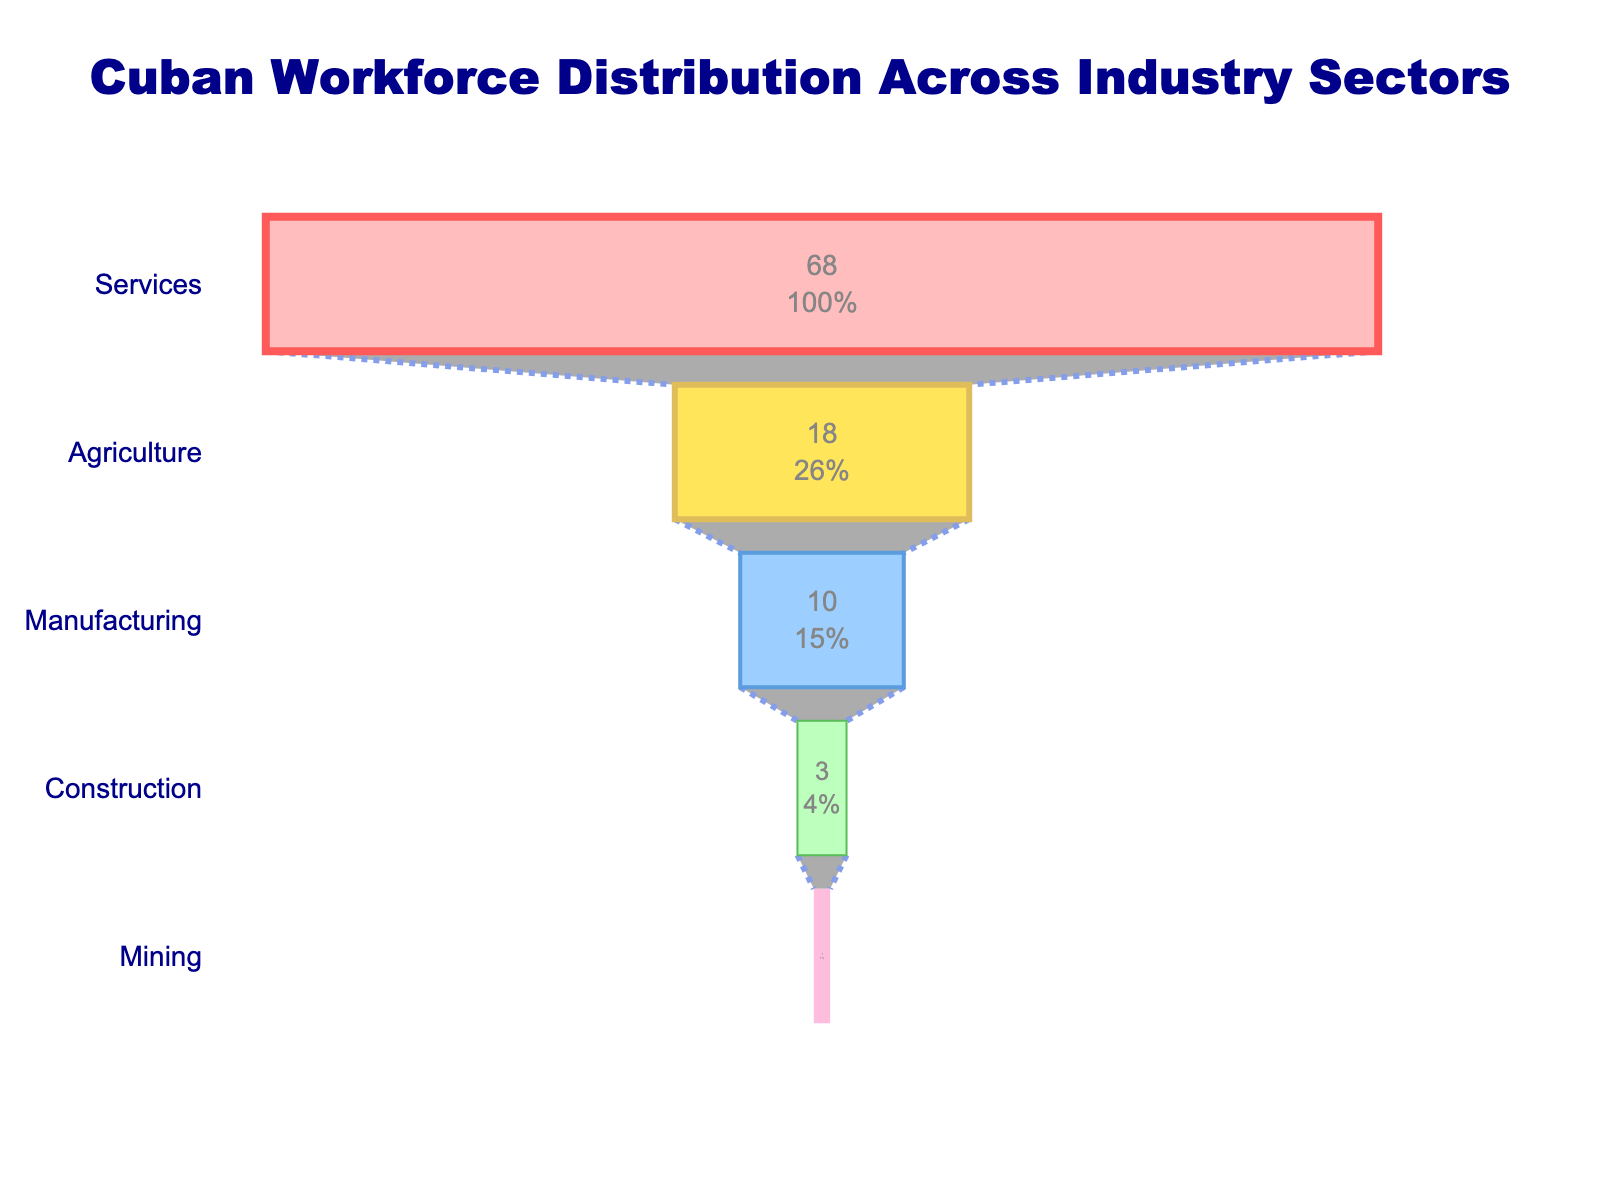what is the title of the figure? The title of the figure can be found at the very top, centered in the layout. It provides a concise description of what the figure is about. The title in this case reads "Cuban Workforce Distribution Across Industry Sectors"
Answer: Cuban Workforce Distribution Across Industry Sectors Which sector has the highest percentage of workforce employment? By examining the width of the sections in the funnel chart, the first (and the widest) section corresponds to the sector with the highest percentage. This sector is "Services".
Answer: Services What is the percentage of workforce in the Manufacturing sector? To find this, look at the section labeled "Manufacturing" and read off the percentage value provided within or beside it, which is 10%.
Answer: 10% Which two sectors combined employ a workforce percentage close to that of the Services sector alone? Services employ 68%. The closest combination of two sectors is Agriculture (18%) and Manufacturing (10%), which together total 28%. Another closer combination comprises Agriculture (18%) + Agriculture (18%), totaling 36%. But, Construction (3%) and Mining (1%) together total 4%.
Answer: Agriculture, Manufacturing If the Mining sector doubled its workforce percentage, what would be its new percentage and how would it compare to the Construction sector? Currently, the Mining sector is at 1%. If it doubled, it would reach 2%. The Construction sector is at 3%, so Mining would still employ fewer people than the Construction sector.
Answer: 2%, less than Construction How many sectors have a workforce percentage less than 20%? By examining the percentages for each sector, we see that Agriculture (18%), Manufacturing (10%), Construction (3%), and Mining (1%) all fall below 20%. That makes 4 sectors.
Answer: 4 What sector employs about half the workforce that the Agriculture sector does? Agriculture employs 18%. Half of 18% would be 9%. The sector closest to this value is Manufacturing, which employs 10%.
Answer: Manufacturing 